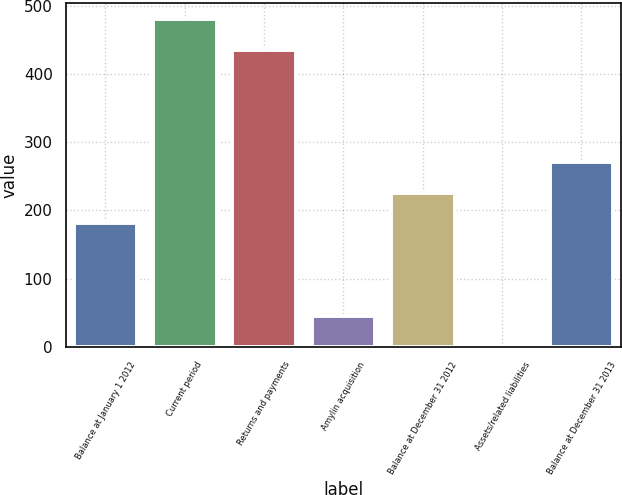Convert chart. <chart><loc_0><loc_0><loc_500><loc_500><bar_chart><fcel>Balance at January 1 2012<fcel>Current period<fcel>Returns and payments<fcel>Amylin acquisition<fcel>Balance at December 31 2012<fcel>Assets/related liabilities<fcel>Balance at December 31 2013<nl><fcel>181<fcel>480<fcel>435<fcel>46<fcel>226<fcel>1<fcel>271<nl></chart> 